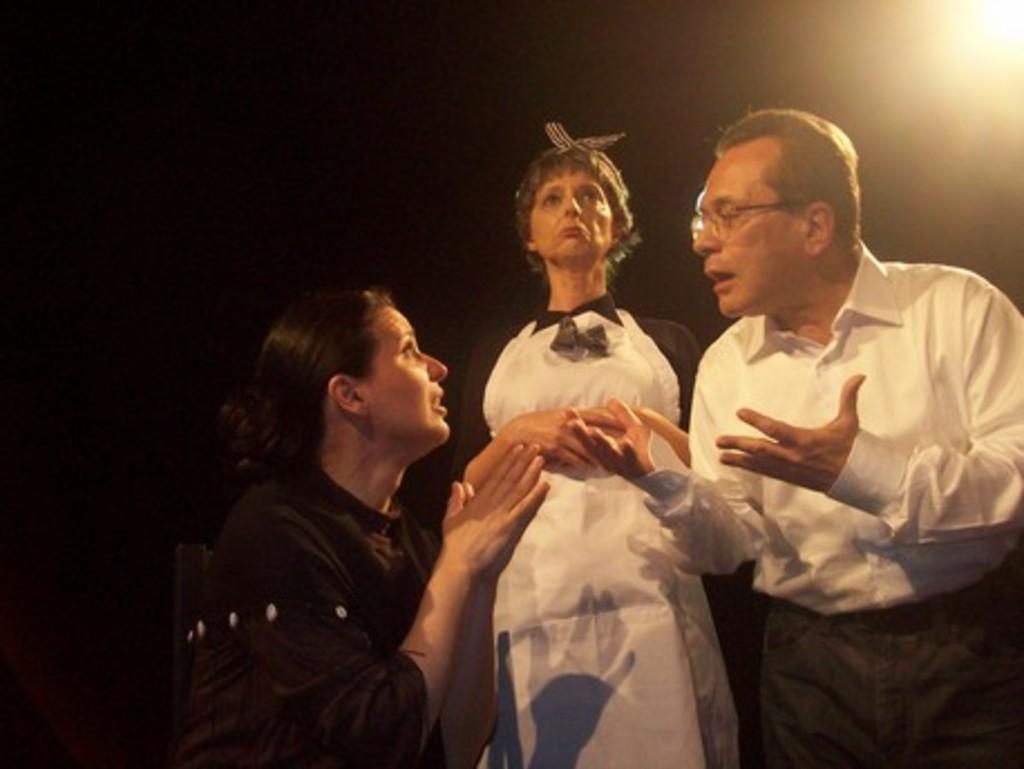How would you summarize this image in a sentence or two? In the foreground of the picture we can see three persons. The picture is looking like it is taken while a drama. In this picture there are two women and a man. In the top right corner there is light. The background is black. 